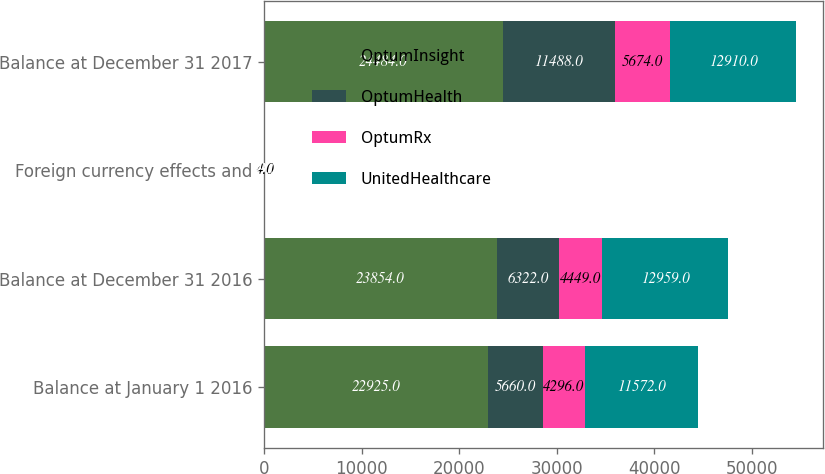<chart> <loc_0><loc_0><loc_500><loc_500><stacked_bar_chart><ecel><fcel>Balance at January 1 2016<fcel>Balance at December 31 2016<fcel>Foreign currency effects and<fcel>Balance at December 31 2017<nl><fcel>OptumInsight<fcel>22925<fcel>23854<fcel>60<fcel>24484<nl><fcel>OptumHealth<fcel>5660<fcel>6322<fcel>23<fcel>11488<nl><fcel>OptumRx<fcel>4296<fcel>4449<fcel>4<fcel>5674<nl><fcel>UnitedHealthcare<fcel>11572<fcel>12959<fcel>49<fcel>12910<nl></chart> 